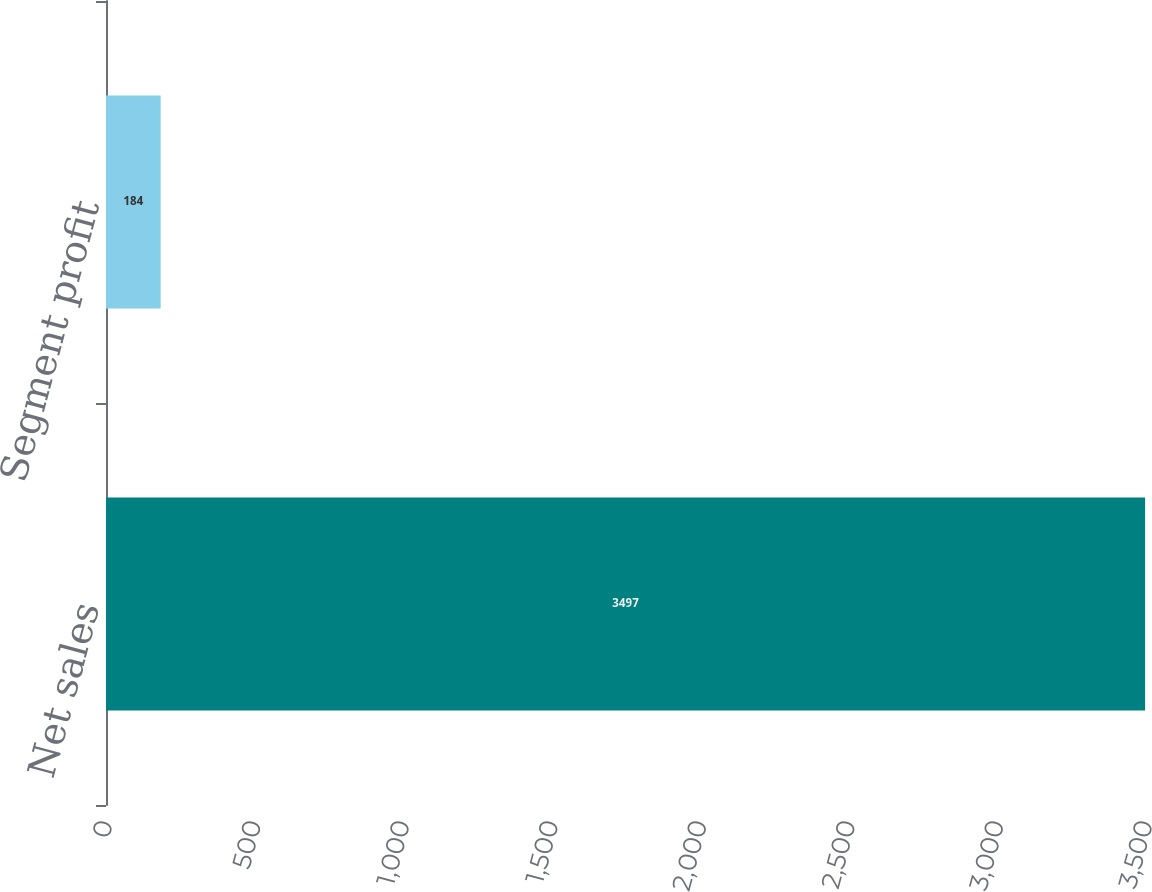Convert chart. <chart><loc_0><loc_0><loc_500><loc_500><bar_chart><fcel>Net sales<fcel>Segment profit<nl><fcel>3497<fcel>184<nl></chart> 